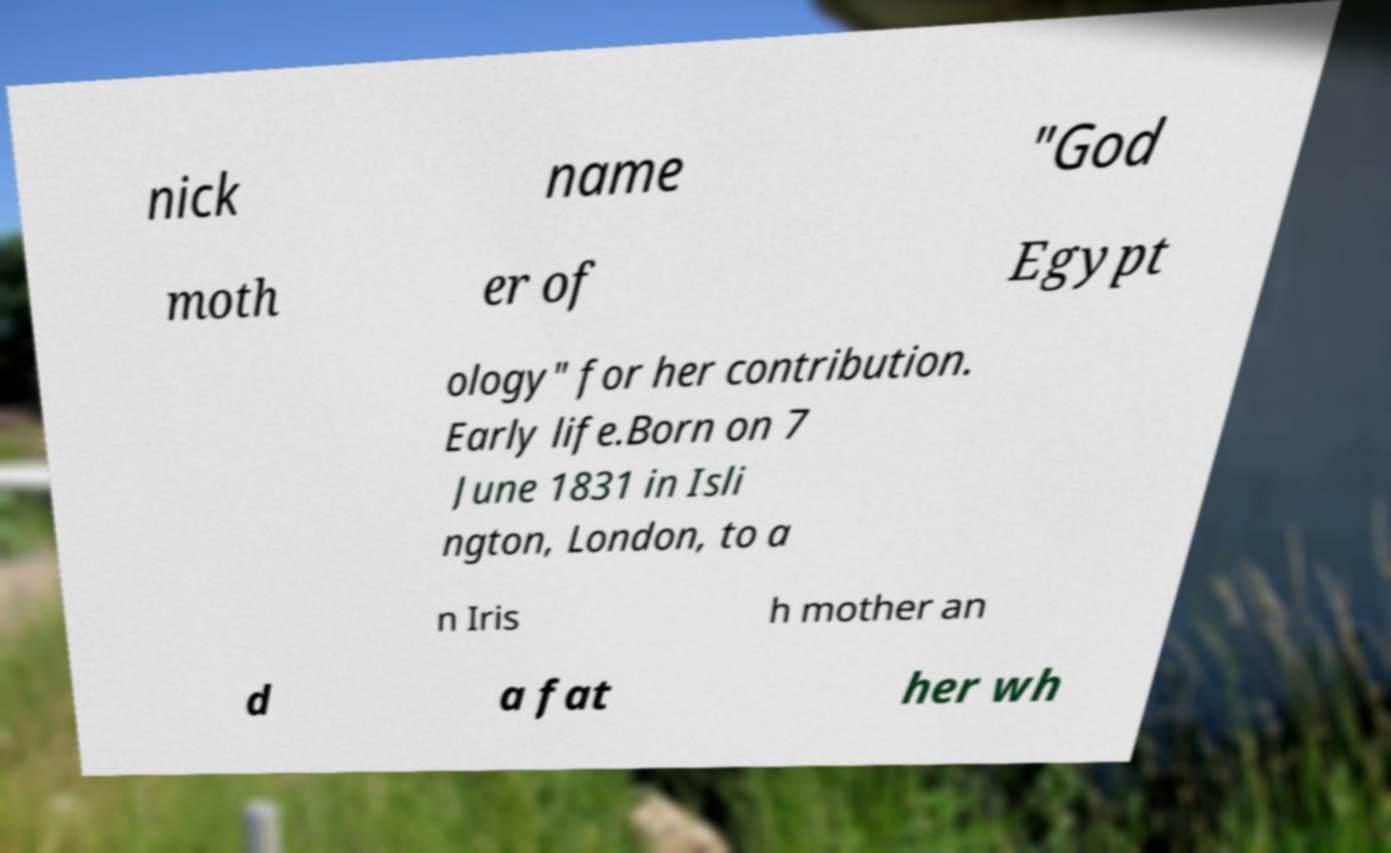Could you assist in decoding the text presented in this image and type it out clearly? nick name "God moth er of Egypt ology" for her contribution. Early life.Born on 7 June 1831 in Isli ngton, London, to a n Iris h mother an d a fat her wh 